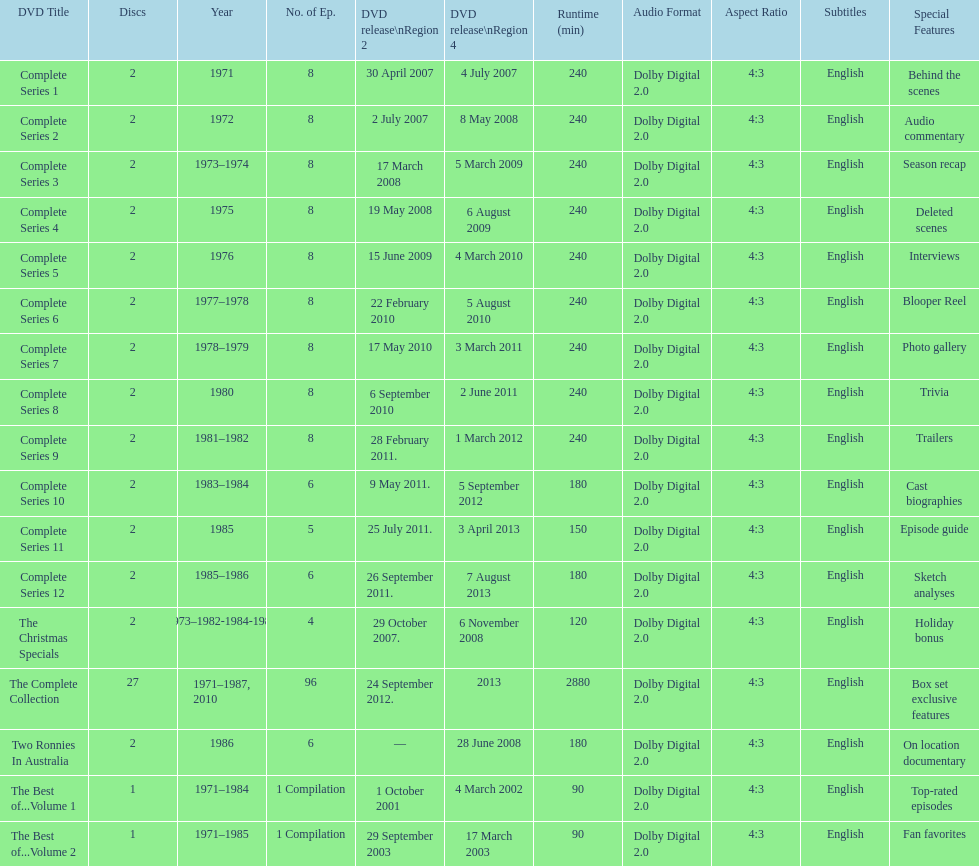Dvd shorter than 5 episodes The Christmas Specials. 